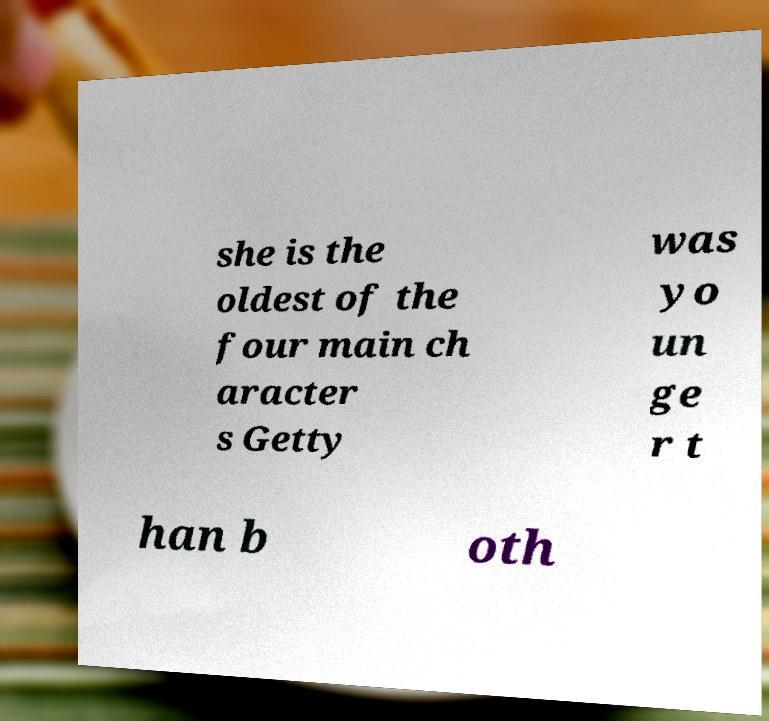What messages or text are displayed in this image? I need them in a readable, typed format. she is the oldest of the four main ch aracter s Getty was yo un ge r t han b oth 